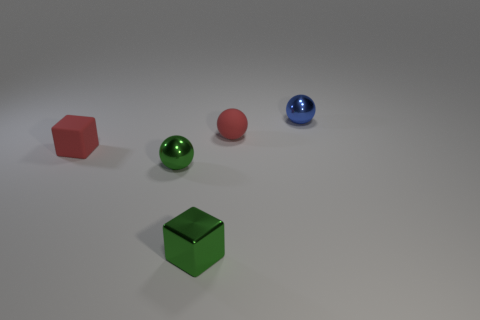Subtract all shiny spheres. How many spheres are left? 1 Add 3 brown blocks. How many objects exist? 8 Subtract all blue spheres. How many spheres are left? 2 Subtract 2 spheres. How many spheres are left? 1 Subtract all blocks. How many objects are left? 3 Subtract all brown cylinders. How many purple balls are left? 0 Subtract all tiny gray balls. Subtract all small rubber cubes. How many objects are left? 4 Add 5 tiny rubber blocks. How many tiny rubber blocks are left? 6 Add 3 metal blocks. How many metal blocks exist? 4 Subtract 0 brown balls. How many objects are left? 5 